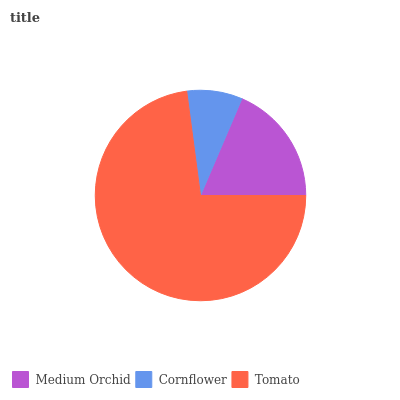Is Cornflower the minimum?
Answer yes or no. Yes. Is Tomato the maximum?
Answer yes or no. Yes. Is Tomato the minimum?
Answer yes or no. No. Is Cornflower the maximum?
Answer yes or no. No. Is Tomato greater than Cornflower?
Answer yes or no. Yes. Is Cornflower less than Tomato?
Answer yes or no. Yes. Is Cornflower greater than Tomato?
Answer yes or no. No. Is Tomato less than Cornflower?
Answer yes or no. No. Is Medium Orchid the high median?
Answer yes or no. Yes. Is Medium Orchid the low median?
Answer yes or no. Yes. Is Tomato the high median?
Answer yes or no. No. Is Tomato the low median?
Answer yes or no. No. 